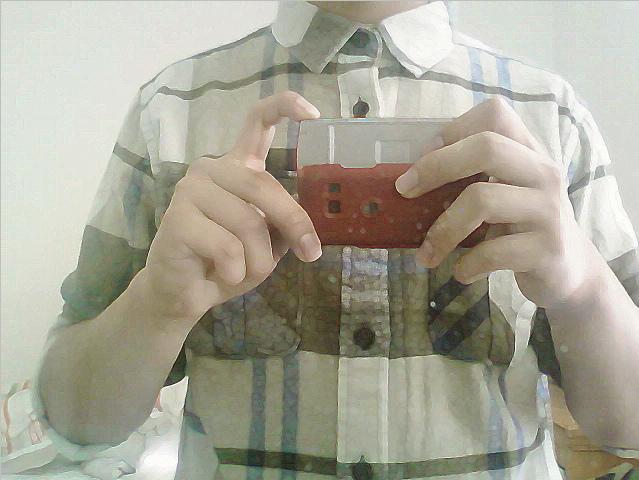Is the shirt buttoned all the way to the top?
Concise answer only. Yes. Is the person wearing rings?
Short answer required. No. What is he doing?
Be succinct. Taking picture. 